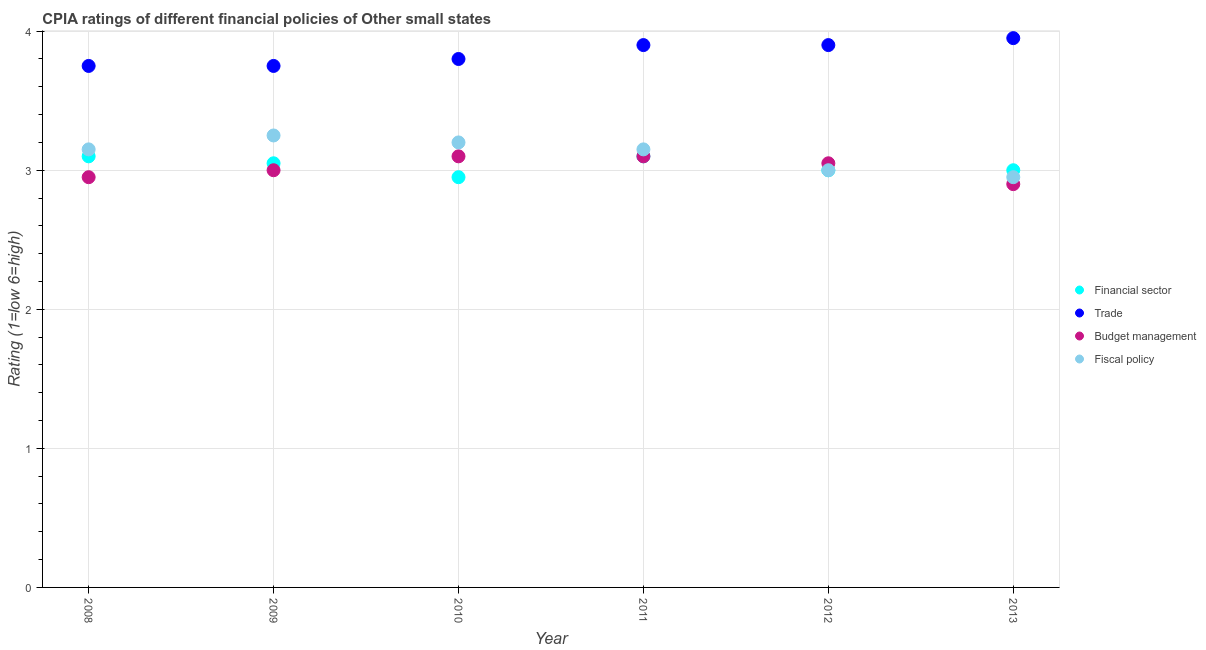How many different coloured dotlines are there?
Provide a succinct answer. 4. What is the cpia rating of financial sector in 2012?
Give a very brief answer. 3. Across all years, what is the maximum cpia rating of financial sector?
Ensure brevity in your answer.  3.1. Across all years, what is the minimum cpia rating of budget management?
Provide a short and direct response. 2.9. In which year was the cpia rating of trade maximum?
Your answer should be compact. 2013. What is the total cpia rating of budget management in the graph?
Keep it short and to the point. 18.1. What is the difference between the cpia rating of trade in 2008 and that in 2013?
Ensure brevity in your answer.  -0.2. What is the difference between the cpia rating of financial sector in 2012 and the cpia rating of fiscal policy in 2008?
Provide a succinct answer. -0.15. What is the average cpia rating of trade per year?
Your answer should be very brief. 3.84. What is the ratio of the cpia rating of budget management in 2009 to that in 2010?
Offer a terse response. 0.97. Is the difference between the cpia rating of fiscal policy in 2008 and 2010 greater than the difference between the cpia rating of budget management in 2008 and 2010?
Keep it short and to the point. Yes. What is the difference between the highest and the second highest cpia rating of fiscal policy?
Provide a succinct answer. 0.05. What is the difference between the highest and the lowest cpia rating of trade?
Offer a very short reply. 0.2. Is it the case that in every year, the sum of the cpia rating of financial sector and cpia rating of fiscal policy is greater than the sum of cpia rating of budget management and cpia rating of trade?
Give a very brief answer. No. Is it the case that in every year, the sum of the cpia rating of financial sector and cpia rating of trade is greater than the cpia rating of budget management?
Your answer should be very brief. Yes. Is the cpia rating of fiscal policy strictly less than the cpia rating of financial sector over the years?
Provide a short and direct response. No. How many dotlines are there?
Your answer should be very brief. 4. How many years are there in the graph?
Your answer should be very brief. 6. Are the values on the major ticks of Y-axis written in scientific E-notation?
Your response must be concise. No. Does the graph contain any zero values?
Offer a very short reply. No. Does the graph contain grids?
Give a very brief answer. Yes. How many legend labels are there?
Your answer should be compact. 4. How are the legend labels stacked?
Give a very brief answer. Vertical. What is the title of the graph?
Give a very brief answer. CPIA ratings of different financial policies of Other small states. What is the label or title of the X-axis?
Your answer should be very brief. Year. What is the label or title of the Y-axis?
Your answer should be very brief. Rating (1=low 6=high). What is the Rating (1=low 6=high) in Trade in 2008?
Make the answer very short. 3.75. What is the Rating (1=low 6=high) of Budget management in 2008?
Your answer should be very brief. 2.95. What is the Rating (1=low 6=high) in Fiscal policy in 2008?
Give a very brief answer. 3.15. What is the Rating (1=low 6=high) of Financial sector in 2009?
Give a very brief answer. 3.05. What is the Rating (1=low 6=high) of Trade in 2009?
Your response must be concise. 3.75. What is the Rating (1=low 6=high) of Financial sector in 2010?
Your answer should be very brief. 2.95. What is the Rating (1=low 6=high) of Trade in 2010?
Your answer should be compact. 3.8. What is the Rating (1=low 6=high) of Budget management in 2010?
Provide a succinct answer. 3.1. What is the Rating (1=low 6=high) of Financial sector in 2011?
Provide a short and direct response. 3.1. What is the Rating (1=low 6=high) in Fiscal policy in 2011?
Make the answer very short. 3.15. What is the Rating (1=low 6=high) in Financial sector in 2012?
Provide a succinct answer. 3. What is the Rating (1=low 6=high) in Trade in 2012?
Your answer should be compact. 3.9. What is the Rating (1=low 6=high) in Budget management in 2012?
Make the answer very short. 3.05. What is the Rating (1=low 6=high) in Trade in 2013?
Provide a short and direct response. 3.95. What is the Rating (1=low 6=high) in Budget management in 2013?
Your answer should be very brief. 2.9. What is the Rating (1=low 6=high) in Fiscal policy in 2013?
Offer a terse response. 2.95. Across all years, what is the maximum Rating (1=low 6=high) in Financial sector?
Make the answer very short. 3.1. Across all years, what is the maximum Rating (1=low 6=high) in Trade?
Offer a terse response. 3.95. Across all years, what is the minimum Rating (1=low 6=high) of Financial sector?
Provide a succinct answer. 2.95. Across all years, what is the minimum Rating (1=low 6=high) in Trade?
Provide a short and direct response. 3.75. Across all years, what is the minimum Rating (1=low 6=high) in Fiscal policy?
Offer a terse response. 2.95. What is the total Rating (1=low 6=high) in Financial sector in the graph?
Ensure brevity in your answer.  18.2. What is the total Rating (1=low 6=high) in Trade in the graph?
Ensure brevity in your answer.  23.05. What is the total Rating (1=low 6=high) in Budget management in the graph?
Keep it short and to the point. 18.1. What is the total Rating (1=low 6=high) of Fiscal policy in the graph?
Keep it short and to the point. 18.7. What is the difference between the Rating (1=low 6=high) of Financial sector in 2008 and that in 2009?
Your answer should be compact. 0.05. What is the difference between the Rating (1=low 6=high) of Fiscal policy in 2008 and that in 2009?
Provide a short and direct response. -0.1. What is the difference between the Rating (1=low 6=high) of Financial sector in 2008 and that in 2010?
Provide a succinct answer. 0.15. What is the difference between the Rating (1=low 6=high) of Financial sector in 2008 and that in 2012?
Your answer should be very brief. 0.1. What is the difference between the Rating (1=low 6=high) in Trade in 2008 and that in 2012?
Keep it short and to the point. -0.15. What is the difference between the Rating (1=low 6=high) in Budget management in 2008 and that in 2012?
Give a very brief answer. -0.1. What is the difference between the Rating (1=low 6=high) in Fiscal policy in 2008 and that in 2012?
Your response must be concise. 0.15. What is the difference between the Rating (1=low 6=high) of Budget management in 2008 and that in 2013?
Ensure brevity in your answer.  0.05. What is the difference between the Rating (1=low 6=high) in Fiscal policy in 2008 and that in 2013?
Keep it short and to the point. 0.2. What is the difference between the Rating (1=low 6=high) in Financial sector in 2009 and that in 2010?
Offer a very short reply. 0.1. What is the difference between the Rating (1=low 6=high) of Trade in 2009 and that in 2010?
Your response must be concise. -0.05. What is the difference between the Rating (1=low 6=high) in Budget management in 2009 and that in 2010?
Give a very brief answer. -0.1. What is the difference between the Rating (1=low 6=high) of Fiscal policy in 2009 and that in 2010?
Ensure brevity in your answer.  0.05. What is the difference between the Rating (1=low 6=high) of Financial sector in 2009 and that in 2011?
Offer a terse response. -0.05. What is the difference between the Rating (1=low 6=high) of Budget management in 2009 and that in 2011?
Keep it short and to the point. -0.1. What is the difference between the Rating (1=low 6=high) of Fiscal policy in 2009 and that in 2011?
Keep it short and to the point. 0.1. What is the difference between the Rating (1=low 6=high) of Budget management in 2009 and that in 2012?
Provide a succinct answer. -0.05. What is the difference between the Rating (1=low 6=high) in Fiscal policy in 2009 and that in 2012?
Provide a succinct answer. 0.25. What is the difference between the Rating (1=low 6=high) of Trade in 2009 and that in 2013?
Offer a very short reply. -0.2. What is the difference between the Rating (1=low 6=high) in Fiscal policy in 2009 and that in 2013?
Make the answer very short. 0.3. What is the difference between the Rating (1=low 6=high) of Trade in 2010 and that in 2011?
Ensure brevity in your answer.  -0.1. What is the difference between the Rating (1=low 6=high) in Budget management in 2010 and that in 2011?
Give a very brief answer. 0. What is the difference between the Rating (1=low 6=high) in Fiscal policy in 2010 and that in 2012?
Your answer should be compact. 0.2. What is the difference between the Rating (1=low 6=high) in Financial sector in 2010 and that in 2013?
Your response must be concise. -0.05. What is the difference between the Rating (1=low 6=high) of Budget management in 2010 and that in 2013?
Offer a very short reply. 0.2. What is the difference between the Rating (1=low 6=high) in Fiscal policy in 2010 and that in 2013?
Ensure brevity in your answer.  0.25. What is the difference between the Rating (1=low 6=high) in Financial sector in 2011 and that in 2012?
Offer a terse response. 0.1. What is the difference between the Rating (1=low 6=high) in Fiscal policy in 2011 and that in 2012?
Your answer should be very brief. 0.15. What is the difference between the Rating (1=low 6=high) in Financial sector in 2011 and that in 2013?
Make the answer very short. 0.1. What is the difference between the Rating (1=low 6=high) in Trade in 2011 and that in 2013?
Offer a terse response. -0.05. What is the difference between the Rating (1=low 6=high) in Budget management in 2011 and that in 2013?
Offer a terse response. 0.2. What is the difference between the Rating (1=low 6=high) in Fiscal policy in 2011 and that in 2013?
Your answer should be very brief. 0.2. What is the difference between the Rating (1=low 6=high) of Financial sector in 2012 and that in 2013?
Offer a very short reply. 0. What is the difference between the Rating (1=low 6=high) in Budget management in 2012 and that in 2013?
Offer a terse response. 0.15. What is the difference between the Rating (1=low 6=high) in Financial sector in 2008 and the Rating (1=low 6=high) in Trade in 2009?
Your answer should be compact. -0.65. What is the difference between the Rating (1=low 6=high) of Trade in 2008 and the Rating (1=low 6=high) of Fiscal policy in 2009?
Offer a terse response. 0.5. What is the difference between the Rating (1=low 6=high) in Budget management in 2008 and the Rating (1=low 6=high) in Fiscal policy in 2009?
Your answer should be compact. -0.3. What is the difference between the Rating (1=low 6=high) in Financial sector in 2008 and the Rating (1=low 6=high) in Trade in 2010?
Give a very brief answer. -0.7. What is the difference between the Rating (1=low 6=high) of Trade in 2008 and the Rating (1=low 6=high) of Budget management in 2010?
Give a very brief answer. 0.65. What is the difference between the Rating (1=low 6=high) of Trade in 2008 and the Rating (1=low 6=high) of Fiscal policy in 2010?
Your answer should be compact. 0.55. What is the difference between the Rating (1=low 6=high) of Financial sector in 2008 and the Rating (1=low 6=high) of Budget management in 2011?
Offer a very short reply. 0. What is the difference between the Rating (1=low 6=high) of Trade in 2008 and the Rating (1=low 6=high) of Budget management in 2011?
Keep it short and to the point. 0.65. What is the difference between the Rating (1=low 6=high) of Budget management in 2008 and the Rating (1=low 6=high) of Fiscal policy in 2011?
Give a very brief answer. -0.2. What is the difference between the Rating (1=low 6=high) in Financial sector in 2008 and the Rating (1=low 6=high) in Trade in 2012?
Make the answer very short. -0.8. What is the difference between the Rating (1=low 6=high) of Financial sector in 2008 and the Rating (1=low 6=high) of Budget management in 2012?
Keep it short and to the point. 0.05. What is the difference between the Rating (1=low 6=high) of Trade in 2008 and the Rating (1=low 6=high) of Fiscal policy in 2012?
Your response must be concise. 0.75. What is the difference between the Rating (1=low 6=high) in Financial sector in 2008 and the Rating (1=low 6=high) in Trade in 2013?
Offer a terse response. -0.85. What is the difference between the Rating (1=low 6=high) in Financial sector in 2008 and the Rating (1=low 6=high) in Fiscal policy in 2013?
Offer a very short reply. 0.15. What is the difference between the Rating (1=low 6=high) in Financial sector in 2009 and the Rating (1=low 6=high) in Trade in 2010?
Make the answer very short. -0.75. What is the difference between the Rating (1=low 6=high) of Financial sector in 2009 and the Rating (1=low 6=high) of Fiscal policy in 2010?
Give a very brief answer. -0.15. What is the difference between the Rating (1=low 6=high) in Trade in 2009 and the Rating (1=low 6=high) in Budget management in 2010?
Offer a very short reply. 0.65. What is the difference between the Rating (1=low 6=high) in Trade in 2009 and the Rating (1=low 6=high) in Fiscal policy in 2010?
Give a very brief answer. 0.55. What is the difference between the Rating (1=low 6=high) in Budget management in 2009 and the Rating (1=low 6=high) in Fiscal policy in 2010?
Provide a succinct answer. -0.2. What is the difference between the Rating (1=low 6=high) in Financial sector in 2009 and the Rating (1=low 6=high) in Trade in 2011?
Your answer should be compact. -0.85. What is the difference between the Rating (1=low 6=high) of Financial sector in 2009 and the Rating (1=low 6=high) of Budget management in 2011?
Offer a terse response. -0.05. What is the difference between the Rating (1=low 6=high) in Trade in 2009 and the Rating (1=low 6=high) in Budget management in 2011?
Your response must be concise. 0.65. What is the difference between the Rating (1=low 6=high) of Budget management in 2009 and the Rating (1=low 6=high) of Fiscal policy in 2011?
Provide a succinct answer. -0.15. What is the difference between the Rating (1=low 6=high) in Financial sector in 2009 and the Rating (1=low 6=high) in Trade in 2012?
Keep it short and to the point. -0.85. What is the difference between the Rating (1=low 6=high) in Financial sector in 2009 and the Rating (1=low 6=high) in Fiscal policy in 2012?
Your answer should be compact. 0.05. What is the difference between the Rating (1=low 6=high) of Trade in 2009 and the Rating (1=low 6=high) of Budget management in 2012?
Give a very brief answer. 0.7. What is the difference between the Rating (1=low 6=high) of Budget management in 2009 and the Rating (1=low 6=high) of Fiscal policy in 2012?
Keep it short and to the point. 0. What is the difference between the Rating (1=low 6=high) in Financial sector in 2009 and the Rating (1=low 6=high) in Fiscal policy in 2013?
Ensure brevity in your answer.  0.1. What is the difference between the Rating (1=low 6=high) of Trade in 2009 and the Rating (1=low 6=high) of Fiscal policy in 2013?
Provide a short and direct response. 0.8. What is the difference between the Rating (1=low 6=high) in Budget management in 2009 and the Rating (1=low 6=high) in Fiscal policy in 2013?
Make the answer very short. 0.05. What is the difference between the Rating (1=low 6=high) of Financial sector in 2010 and the Rating (1=low 6=high) of Trade in 2011?
Make the answer very short. -0.95. What is the difference between the Rating (1=low 6=high) in Financial sector in 2010 and the Rating (1=low 6=high) in Budget management in 2011?
Offer a terse response. -0.15. What is the difference between the Rating (1=low 6=high) of Trade in 2010 and the Rating (1=low 6=high) of Fiscal policy in 2011?
Make the answer very short. 0.65. What is the difference between the Rating (1=low 6=high) of Budget management in 2010 and the Rating (1=low 6=high) of Fiscal policy in 2011?
Your response must be concise. -0.05. What is the difference between the Rating (1=low 6=high) in Financial sector in 2010 and the Rating (1=low 6=high) in Trade in 2012?
Give a very brief answer. -0.95. What is the difference between the Rating (1=low 6=high) in Trade in 2010 and the Rating (1=low 6=high) in Budget management in 2012?
Your response must be concise. 0.75. What is the difference between the Rating (1=low 6=high) in Budget management in 2010 and the Rating (1=low 6=high) in Fiscal policy in 2012?
Your response must be concise. 0.1. What is the difference between the Rating (1=low 6=high) in Financial sector in 2010 and the Rating (1=low 6=high) in Fiscal policy in 2013?
Your answer should be compact. 0. What is the difference between the Rating (1=low 6=high) of Budget management in 2010 and the Rating (1=low 6=high) of Fiscal policy in 2013?
Your response must be concise. 0.15. What is the difference between the Rating (1=low 6=high) in Financial sector in 2011 and the Rating (1=low 6=high) in Trade in 2012?
Ensure brevity in your answer.  -0.8. What is the difference between the Rating (1=low 6=high) in Financial sector in 2011 and the Rating (1=low 6=high) in Budget management in 2012?
Provide a short and direct response. 0.05. What is the difference between the Rating (1=low 6=high) in Trade in 2011 and the Rating (1=low 6=high) in Fiscal policy in 2012?
Your response must be concise. 0.9. What is the difference between the Rating (1=low 6=high) of Financial sector in 2011 and the Rating (1=low 6=high) of Trade in 2013?
Offer a very short reply. -0.85. What is the difference between the Rating (1=low 6=high) in Budget management in 2011 and the Rating (1=low 6=high) in Fiscal policy in 2013?
Give a very brief answer. 0.15. What is the difference between the Rating (1=low 6=high) in Financial sector in 2012 and the Rating (1=low 6=high) in Trade in 2013?
Your answer should be compact. -0.95. What is the difference between the Rating (1=low 6=high) in Financial sector in 2012 and the Rating (1=low 6=high) in Budget management in 2013?
Give a very brief answer. 0.1. What is the average Rating (1=low 6=high) in Financial sector per year?
Your response must be concise. 3.03. What is the average Rating (1=low 6=high) in Trade per year?
Make the answer very short. 3.84. What is the average Rating (1=low 6=high) of Budget management per year?
Your answer should be very brief. 3.02. What is the average Rating (1=low 6=high) in Fiscal policy per year?
Make the answer very short. 3.12. In the year 2008, what is the difference between the Rating (1=low 6=high) in Financial sector and Rating (1=low 6=high) in Trade?
Provide a short and direct response. -0.65. In the year 2008, what is the difference between the Rating (1=low 6=high) of Financial sector and Rating (1=low 6=high) of Fiscal policy?
Provide a succinct answer. -0.05. In the year 2008, what is the difference between the Rating (1=low 6=high) of Trade and Rating (1=low 6=high) of Budget management?
Keep it short and to the point. 0.8. In the year 2008, what is the difference between the Rating (1=low 6=high) of Trade and Rating (1=low 6=high) of Fiscal policy?
Make the answer very short. 0.6. In the year 2008, what is the difference between the Rating (1=low 6=high) in Budget management and Rating (1=low 6=high) in Fiscal policy?
Keep it short and to the point. -0.2. In the year 2010, what is the difference between the Rating (1=low 6=high) in Financial sector and Rating (1=low 6=high) in Trade?
Provide a short and direct response. -0.85. In the year 2010, what is the difference between the Rating (1=low 6=high) in Financial sector and Rating (1=low 6=high) in Budget management?
Provide a succinct answer. -0.15. In the year 2010, what is the difference between the Rating (1=low 6=high) in Financial sector and Rating (1=low 6=high) in Fiscal policy?
Ensure brevity in your answer.  -0.25. In the year 2010, what is the difference between the Rating (1=low 6=high) of Trade and Rating (1=low 6=high) of Budget management?
Offer a very short reply. 0.7. In the year 2010, what is the difference between the Rating (1=low 6=high) of Budget management and Rating (1=low 6=high) of Fiscal policy?
Your answer should be very brief. -0.1. In the year 2011, what is the difference between the Rating (1=low 6=high) in Financial sector and Rating (1=low 6=high) in Trade?
Provide a short and direct response. -0.8. In the year 2011, what is the difference between the Rating (1=low 6=high) in Financial sector and Rating (1=low 6=high) in Budget management?
Offer a very short reply. 0. In the year 2012, what is the difference between the Rating (1=low 6=high) of Financial sector and Rating (1=low 6=high) of Trade?
Offer a terse response. -0.9. In the year 2012, what is the difference between the Rating (1=low 6=high) in Financial sector and Rating (1=low 6=high) in Budget management?
Provide a short and direct response. -0.05. In the year 2013, what is the difference between the Rating (1=low 6=high) in Financial sector and Rating (1=low 6=high) in Trade?
Make the answer very short. -0.95. In the year 2013, what is the difference between the Rating (1=low 6=high) of Financial sector and Rating (1=low 6=high) of Budget management?
Provide a succinct answer. 0.1. In the year 2013, what is the difference between the Rating (1=low 6=high) of Trade and Rating (1=low 6=high) of Budget management?
Ensure brevity in your answer.  1.05. In the year 2013, what is the difference between the Rating (1=low 6=high) in Trade and Rating (1=low 6=high) in Fiscal policy?
Your answer should be very brief. 1. In the year 2013, what is the difference between the Rating (1=low 6=high) in Budget management and Rating (1=low 6=high) in Fiscal policy?
Your answer should be compact. -0.05. What is the ratio of the Rating (1=low 6=high) in Financial sector in 2008 to that in 2009?
Your answer should be compact. 1.02. What is the ratio of the Rating (1=low 6=high) in Trade in 2008 to that in 2009?
Offer a very short reply. 1. What is the ratio of the Rating (1=low 6=high) in Budget management in 2008 to that in 2009?
Make the answer very short. 0.98. What is the ratio of the Rating (1=low 6=high) in Fiscal policy in 2008 to that in 2009?
Keep it short and to the point. 0.97. What is the ratio of the Rating (1=low 6=high) of Financial sector in 2008 to that in 2010?
Provide a short and direct response. 1.05. What is the ratio of the Rating (1=low 6=high) of Trade in 2008 to that in 2010?
Make the answer very short. 0.99. What is the ratio of the Rating (1=low 6=high) of Budget management in 2008 to that in 2010?
Offer a terse response. 0.95. What is the ratio of the Rating (1=low 6=high) of Fiscal policy in 2008 to that in 2010?
Provide a short and direct response. 0.98. What is the ratio of the Rating (1=low 6=high) in Financial sector in 2008 to that in 2011?
Your response must be concise. 1. What is the ratio of the Rating (1=low 6=high) of Trade in 2008 to that in 2011?
Give a very brief answer. 0.96. What is the ratio of the Rating (1=low 6=high) in Budget management in 2008 to that in 2011?
Offer a terse response. 0.95. What is the ratio of the Rating (1=low 6=high) of Fiscal policy in 2008 to that in 2011?
Offer a terse response. 1. What is the ratio of the Rating (1=low 6=high) in Trade in 2008 to that in 2012?
Ensure brevity in your answer.  0.96. What is the ratio of the Rating (1=low 6=high) in Budget management in 2008 to that in 2012?
Ensure brevity in your answer.  0.97. What is the ratio of the Rating (1=low 6=high) in Financial sector in 2008 to that in 2013?
Your answer should be very brief. 1.03. What is the ratio of the Rating (1=low 6=high) in Trade in 2008 to that in 2013?
Give a very brief answer. 0.95. What is the ratio of the Rating (1=low 6=high) in Budget management in 2008 to that in 2013?
Offer a very short reply. 1.02. What is the ratio of the Rating (1=low 6=high) of Fiscal policy in 2008 to that in 2013?
Provide a short and direct response. 1.07. What is the ratio of the Rating (1=low 6=high) of Financial sector in 2009 to that in 2010?
Your answer should be compact. 1.03. What is the ratio of the Rating (1=low 6=high) in Trade in 2009 to that in 2010?
Provide a succinct answer. 0.99. What is the ratio of the Rating (1=low 6=high) of Budget management in 2009 to that in 2010?
Ensure brevity in your answer.  0.97. What is the ratio of the Rating (1=low 6=high) in Fiscal policy in 2009 to that in 2010?
Ensure brevity in your answer.  1.02. What is the ratio of the Rating (1=low 6=high) of Financial sector in 2009 to that in 2011?
Your answer should be very brief. 0.98. What is the ratio of the Rating (1=low 6=high) of Trade in 2009 to that in 2011?
Offer a very short reply. 0.96. What is the ratio of the Rating (1=low 6=high) of Budget management in 2009 to that in 2011?
Offer a very short reply. 0.97. What is the ratio of the Rating (1=low 6=high) of Fiscal policy in 2009 to that in 2011?
Provide a short and direct response. 1.03. What is the ratio of the Rating (1=low 6=high) in Financial sector in 2009 to that in 2012?
Offer a very short reply. 1.02. What is the ratio of the Rating (1=low 6=high) in Trade in 2009 to that in 2012?
Offer a terse response. 0.96. What is the ratio of the Rating (1=low 6=high) in Budget management in 2009 to that in 2012?
Provide a succinct answer. 0.98. What is the ratio of the Rating (1=low 6=high) in Financial sector in 2009 to that in 2013?
Give a very brief answer. 1.02. What is the ratio of the Rating (1=low 6=high) of Trade in 2009 to that in 2013?
Your answer should be compact. 0.95. What is the ratio of the Rating (1=low 6=high) of Budget management in 2009 to that in 2013?
Make the answer very short. 1.03. What is the ratio of the Rating (1=low 6=high) of Fiscal policy in 2009 to that in 2013?
Offer a very short reply. 1.1. What is the ratio of the Rating (1=low 6=high) in Financial sector in 2010 to that in 2011?
Keep it short and to the point. 0.95. What is the ratio of the Rating (1=low 6=high) in Trade in 2010 to that in 2011?
Make the answer very short. 0.97. What is the ratio of the Rating (1=low 6=high) of Budget management in 2010 to that in 2011?
Offer a terse response. 1. What is the ratio of the Rating (1=low 6=high) in Fiscal policy in 2010 to that in 2011?
Provide a short and direct response. 1.02. What is the ratio of the Rating (1=low 6=high) in Financial sector in 2010 to that in 2012?
Your answer should be compact. 0.98. What is the ratio of the Rating (1=low 6=high) in Trade in 2010 to that in 2012?
Your answer should be compact. 0.97. What is the ratio of the Rating (1=low 6=high) in Budget management in 2010 to that in 2012?
Your response must be concise. 1.02. What is the ratio of the Rating (1=low 6=high) of Fiscal policy in 2010 to that in 2012?
Make the answer very short. 1.07. What is the ratio of the Rating (1=low 6=high) in Financial sector in 2010 to that in 2013?
Keep it short and to the point. 0.98. What is the ratio of the Rating (1=low 6=high) in Budget management in 2010 to that in 2013?
Offer a very short reply. 1.07. What is the ratio of the Rating (1=low 6=high) of Fiscal policy in 2010 to that in 2013?
Keep it short and to the point. 1.08. What is the ratio of the Rating (1=low 6=high) of Budget management in 2011 to that in 2012?
Offer a very short reply. 1.02. What is the ratio of the Rating (1=low 6=high) in Financial sector in 2011 to that in 2013?
Your response must be concise. 1.03. What is the ratio of the Rating (1=low 6=high) in Trade in 2011 to that in 2013?
Keep it short and to the point. 0.99. What is the ratio of the Rating (1=low 6=high) in Budget management in 2011 to that in 2013?
Offer a very short reply. 1.07. What is the ratio of the Rating (1=low 6=high) of Fiscal policy in 2011 to that in 2013?
Provide a succinct answer. 1.07. What is the ratio of the Rating (1=low 6=high) in Financial sector in 2012 to that in 2013?
Give a very brief answer. 1. What is the ratio of the Rating (1=low 6=high) in Trade in 2012 to that in 2013?
Provide a short and direct response. 0.99. What is the ratio of the Rating (1=low 6=high) of Budget management in 2012 to that in 2013?
Keep it short and to the point. 1.05. What is the ratio of the Rating (1=low 6=high) in Fiscal policy in 2012 to that in 2013?
Your answer should be very brief. 1.02. What is the difference between the highest and the second highest Rating (1=low 6=high) of Financial sector?
Provide a succinct answer. 0. What is the difference between the highest and the second highest Rating (1=low 6=high) of Fiscal policy?
Your answer should be compact. 0.05. What is the difference between the highest and the lowest Rating (1=low 6=high) of Financial sector?
Offer a very short reply. 0.15. What is the difference between the highest and the lowest Rating (1=low 6=high) in Trade?
Your answer should be compact. 0.2. What is the difference between the highest and the lowest Rating (1=low 6=high) of Budget management?
Make the answer very short. 0.2. 